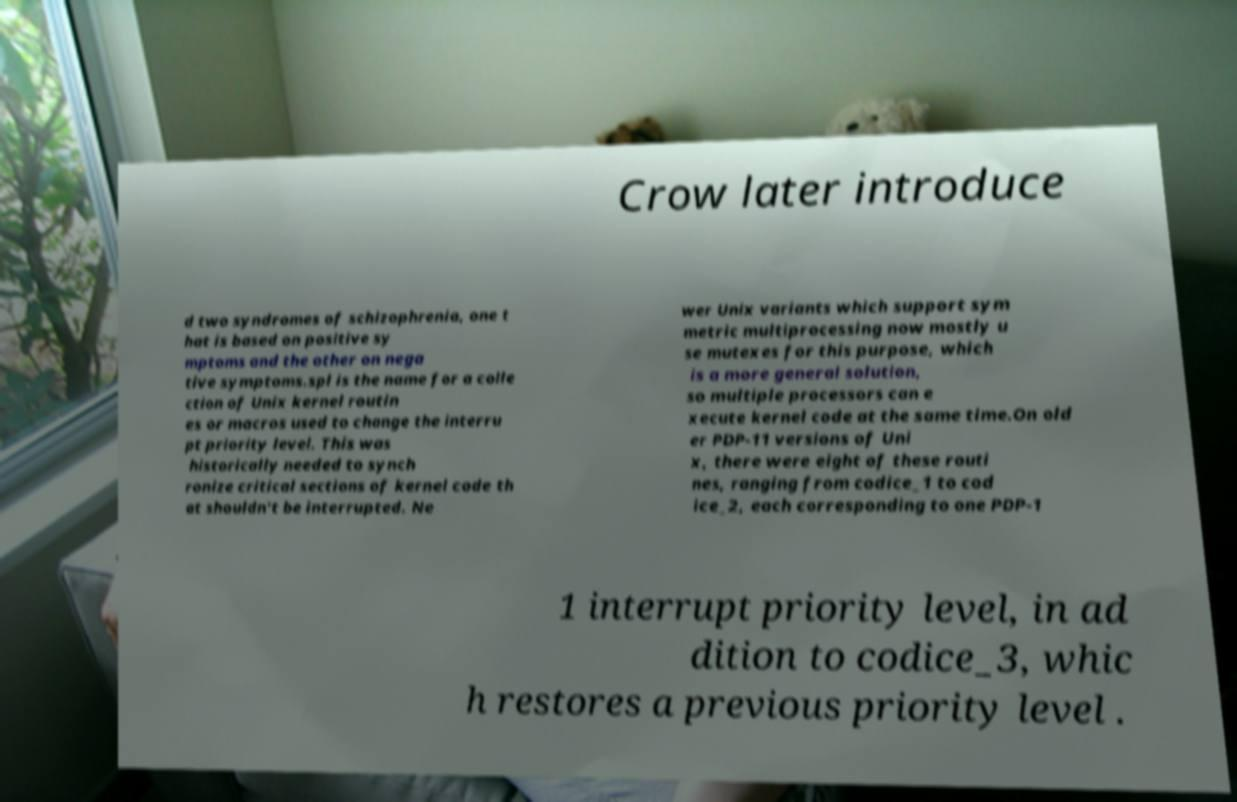Could you assist in decoding the text presented in this image and type it out clearly? Crow later introduce d two syndromes of schizophrenia, one t hat is based on positive sy mptoms and the other on nega tive symptoms.spl is the name for a colle ction of Unix kernel routin es or macros used to change the interru pt priority level. This was historically needed to synch ronize critical sections of kernel code th at shouldn't be interrupted. Ne wer Unix variants which support sym metric multiprocessing now mostly u se mutexes for this purpose, which is a more general solution, so multiple processors can e xecute kernel code at the same time.On old er PDP-11 versions of Uni x, there were eight of these routi nes, ranging from codice_1 to cod ice_2, each corresponding to one PDP-1 1 interrupt priority level, in ad dition to codice_3, whic h restores a previous priority level . 